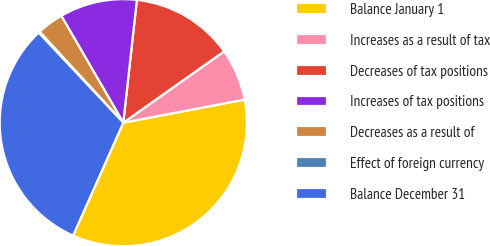<chart> <loc_0><loc_0><loc_500><loc_500><pie_chart><fcel>Balance January 1<fcel>Increases as a result of tax<fcel>Decreases of tax positions<fcel>Increases of tax positions<fcel>Decreases as a result of<fcel>Effect of foreign currency<fcel>Balance December 31<nl><fcel>34.66%<fcel>6.8%<fcel>13.45%<fcel>10.12%<fcel>3.48%<fcel>0.16%<fcel>31.33%<nl></chart> 